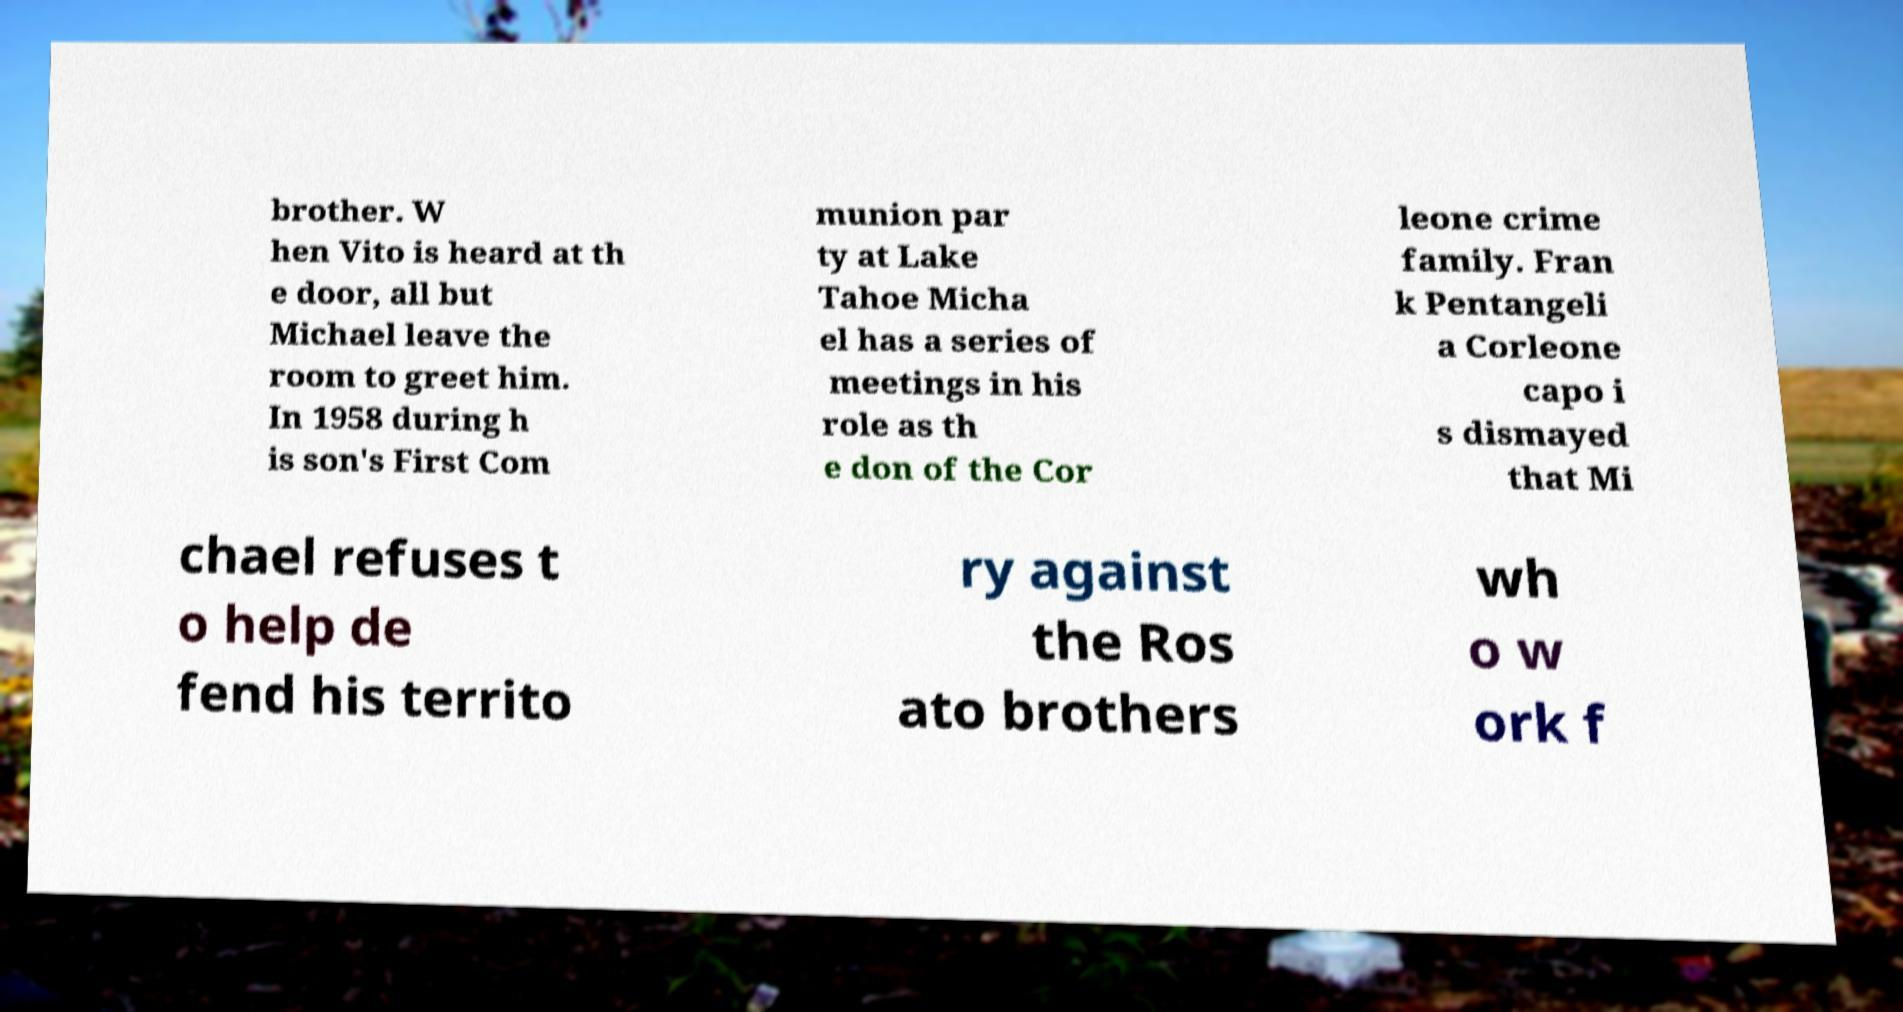Can you accurately transcribe the text from the provided image for me? brother. W hen Vito is heard at th e door, all but Michael leave the room to greet him. In 1958 during h is son's First Com munion par ty at Lake Tahoe Micha el has a series of meetings in his role as th e don of the Cor leone crime family. Fran k Pentangeli a Corleone capo i s dismayed that Mi chael refuses t o help de fend his territo ry against the Ros ato brothers wh o w ork f 